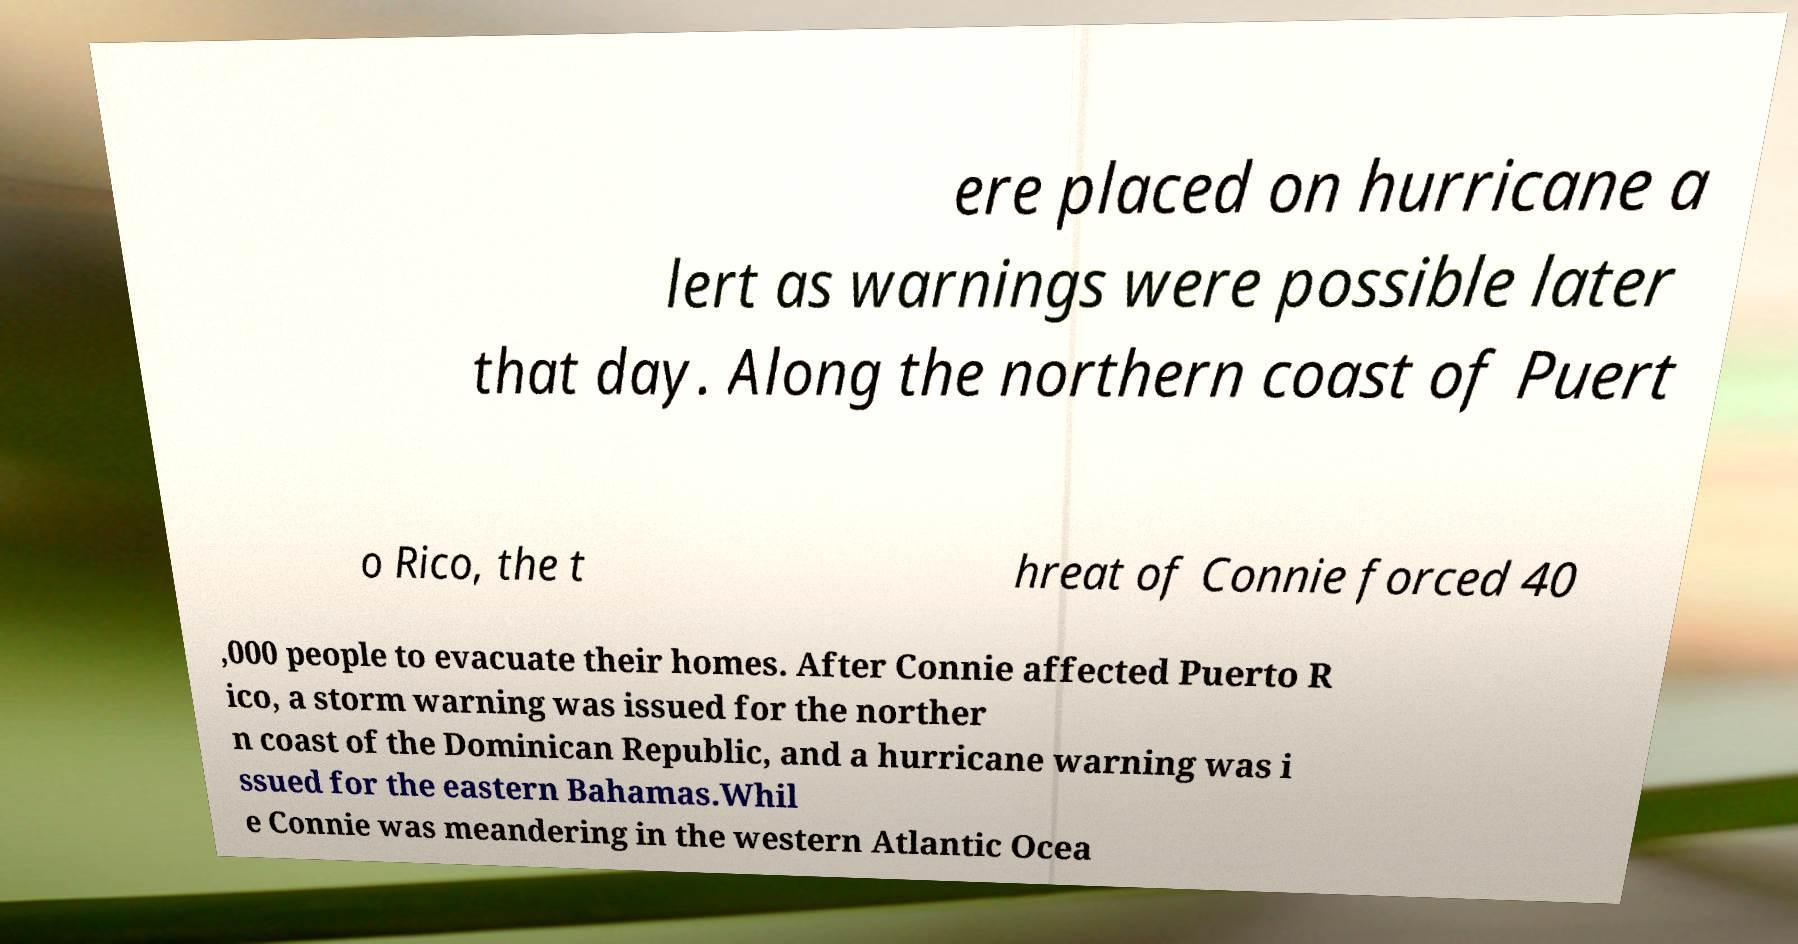Can you accurately transcribe the text from the provided image for me? ere placed on hurricane a lert as warnings were possible later that day. Along the northern coast of Puert o Rico, the t hreat of Connie forced 40 ,000 people to evacuate their homes. After Connie affected Puerto R ico, a storm warning was issued for the norther n coast of the Dominican Republic, and a hurricane warning was i ssued for the eastern Bahamas.Whil e Connie was meandering in the western Atlantic Ocea 